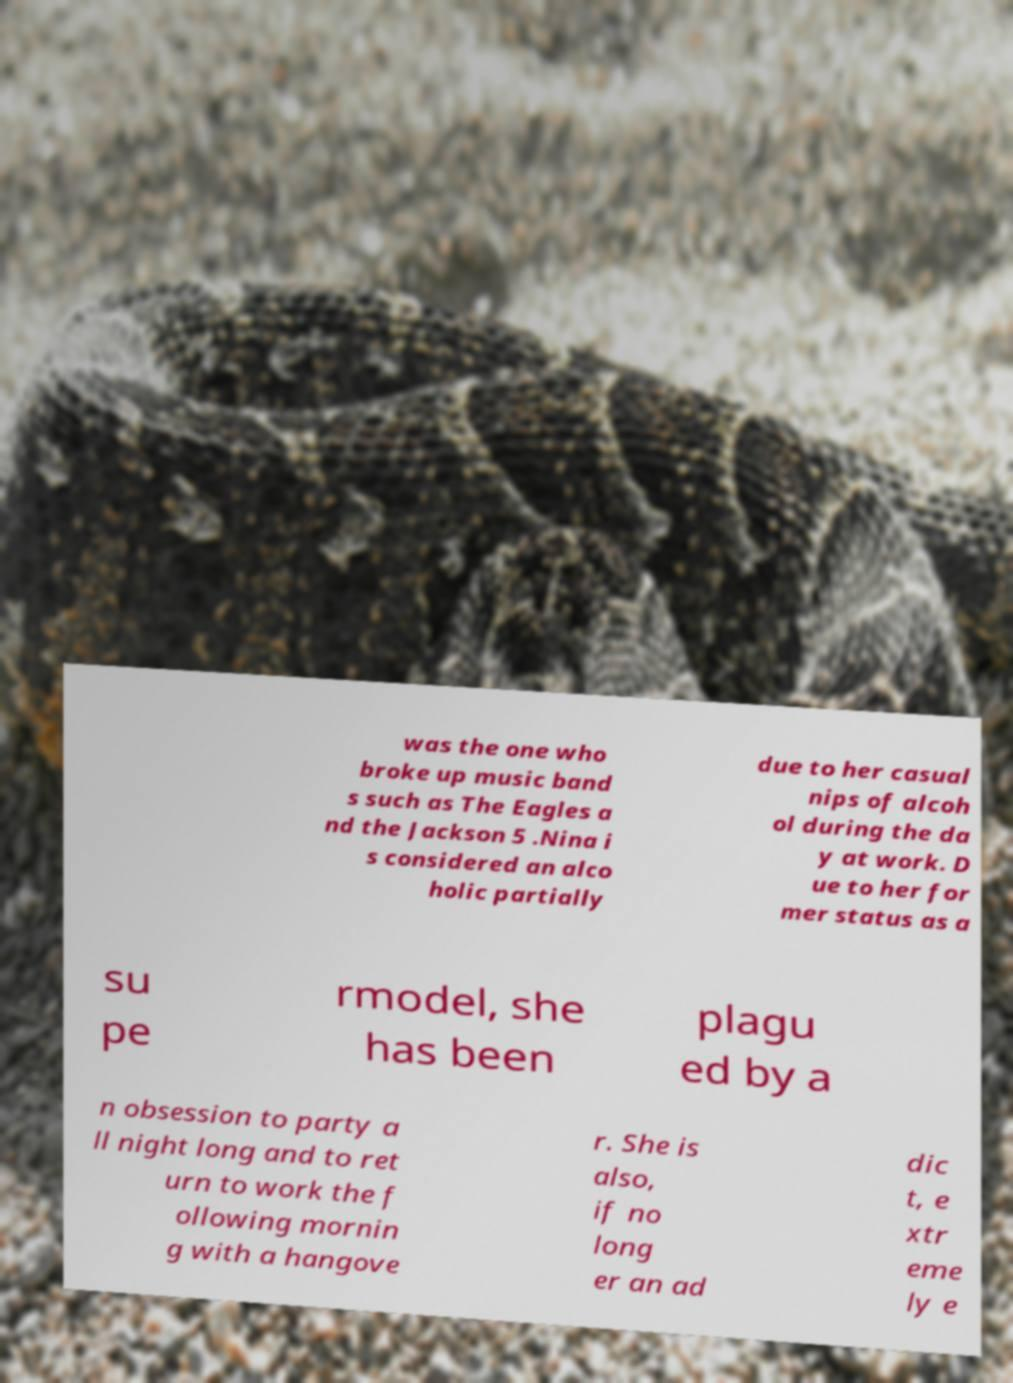There's text embedded in this image that I need extracted. Can you transcribe it verbatim? was the one who broke up music band s such as The Eagles a nd the Jackson 5 .Nina i s considered an alco holic partially due to her casual nips of alcoh ol during the da y at work. D ue to her for mer status as a su pe rmodel, she has been plagu ed by a n obsession to party a ll night long and to ret urn to work the f ollowing mornin g with a hangove r. She is also, if no long er an ad dic t, e xtr eme ly e 